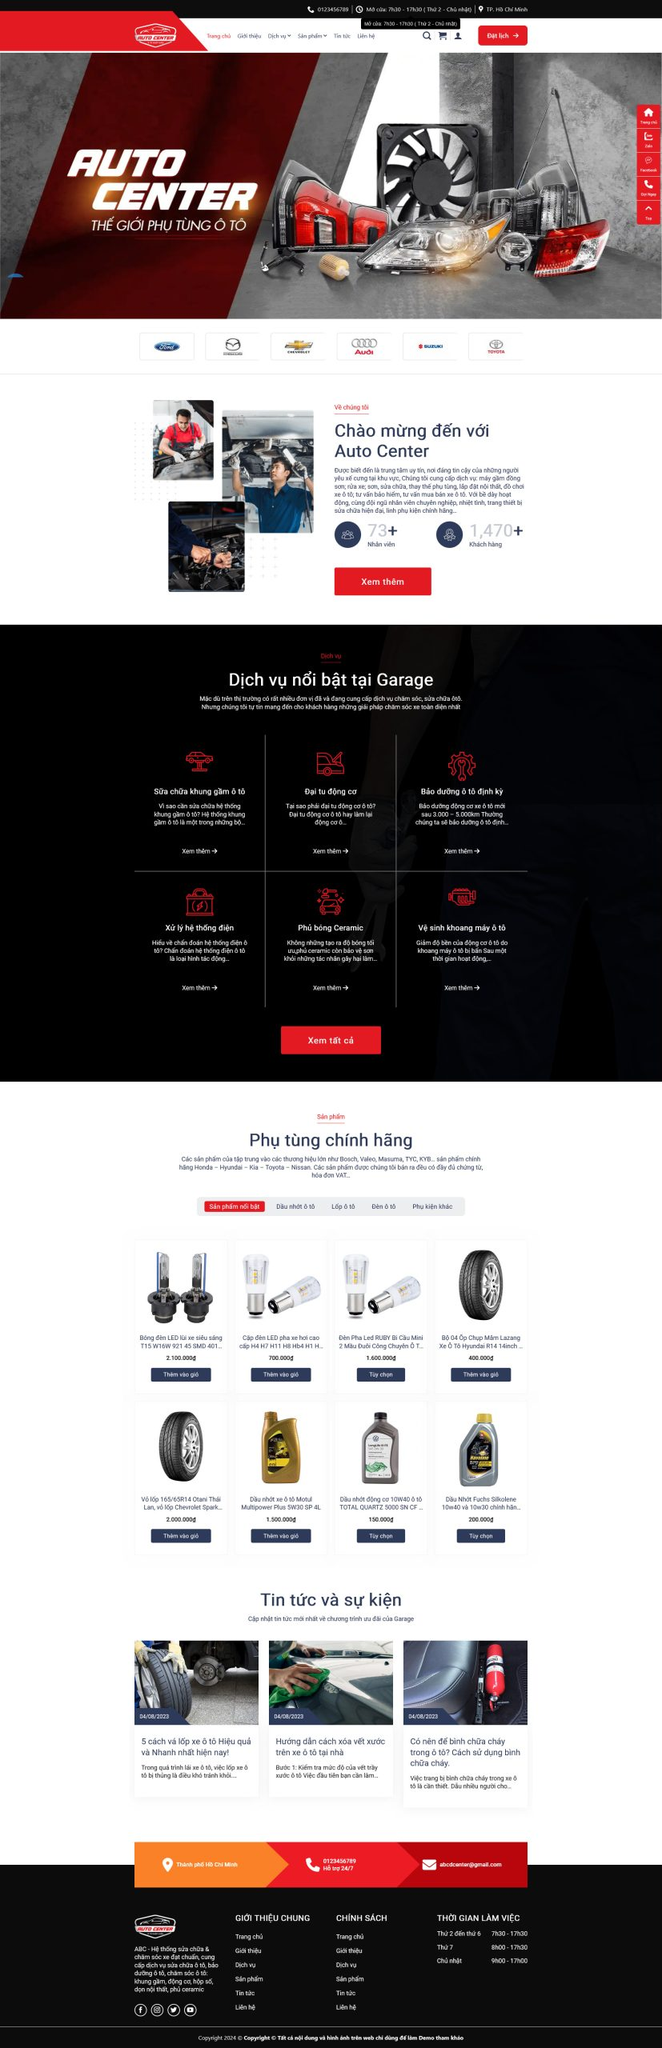Liệt kê 5 ngành nghề, lĩnh vực phù hợp với website này, phân cách các màu sắc bằng dấu phẩy. Chỉ trả về kết quả, phân cách bằng dấy phẩy
 Phụ tùng ô tô, Sửa chữa ô tô, Bảo dưỡng ô tô, Đại tu động cơ, Vệ sinh khoang máy ô tô 